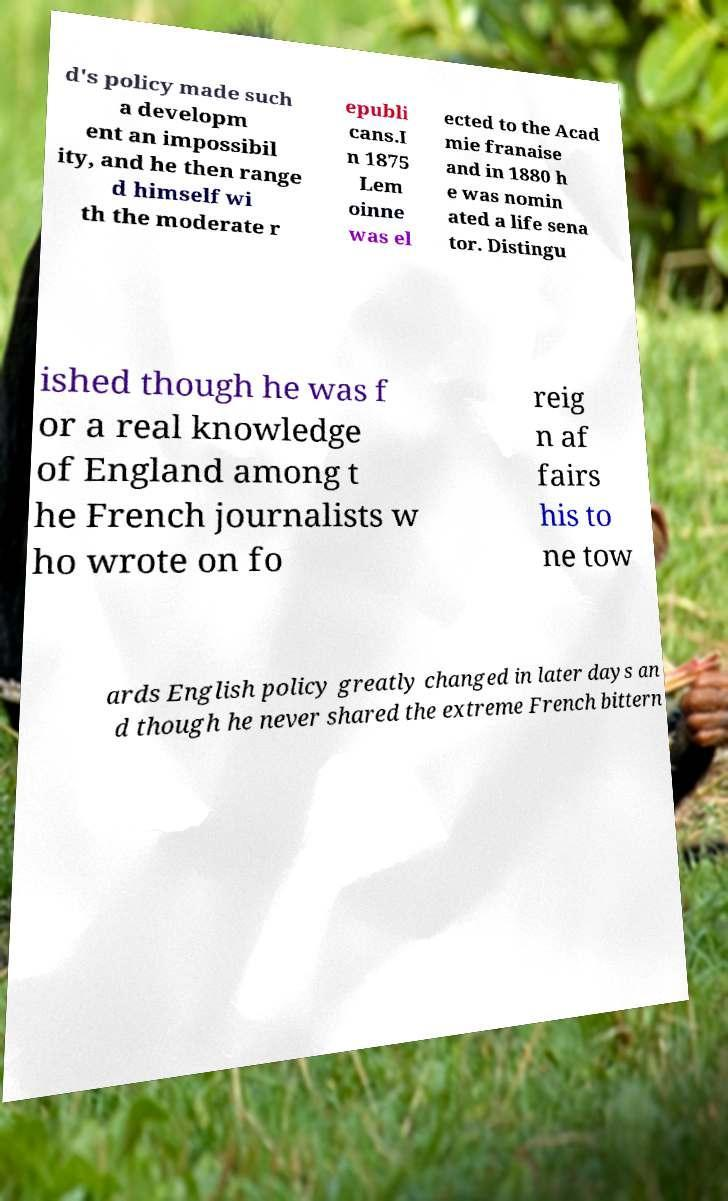What messages or text are displayed in this image? I need them in a readable, typed format. d's policy made such a developm ent an impossibil ity, and he then range d himself wi th the moderate r epubli cans.I n 1875 Lem oinne was el ected to the Acad mie franaise and in 1880 h e was nomin ated a life sena tor. Distingu ished though he was f or a real knowledge of England among t he French journalists w ho wrote on fo reig n af fairs his to ne tow ards English policy greatly changed in later days an d though he never shared the extreme French bittern 